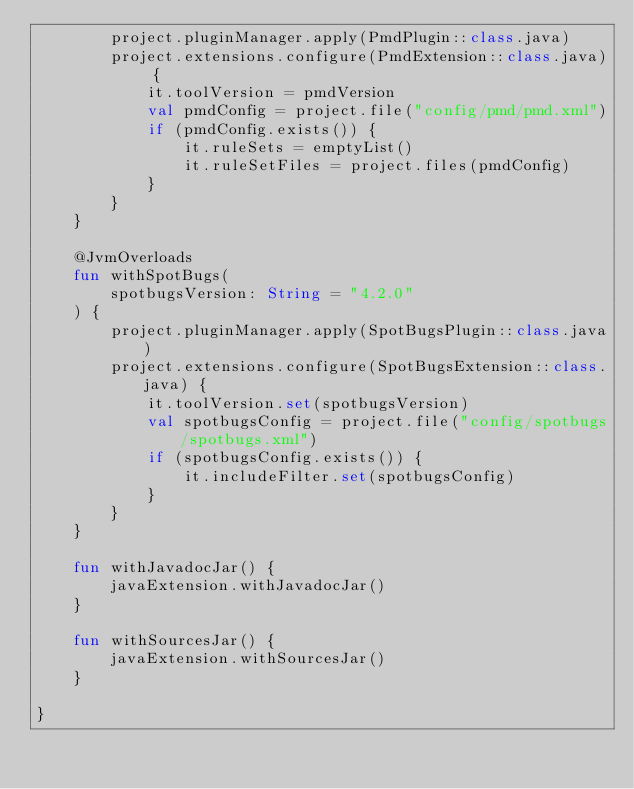<code> <loc_0><loc_0><loc_500><loc_500><_Kotlin_>        project.pluginManager.apply(PmdPlugin::class.java)
        project.extensions.configure(PmdExtension::class.java) {
            it.toolVersion = pmdVersion
            val pmdConfig = project.file("config/pmd/pmd.xml")
            if (pmdConfig.exists()) {
                it.ruleSets = emptyList()
                it.ruleSetFiles = project.files(pmdConfig)
            }
        }
    }

    @JvmOverloads
    fun withSpotBugs(
        spotbugsVersion: String = "4.2.0"
    ) {
        project.pluginManager.apply(SpotBugsPlugin::class.java)
        project.extensions.configure(SpotBugsExtension::class.java) {
            it.toolVersion.set(spotbugsVersion)
            val spotbugsConfig = project.file("config/spotbugs/spotbugs.xml")
            if (spotbugsConfig.exists()) {
                it.includeFilter.set(spotbugsConfig)
            }
        }
    }

    fun withJavadocJar() {
        javaExtension.withJavadocJar()
    }

    fun withSourcesJar() {
        javaExtension.withSourcesJar()
    }

}</code> 